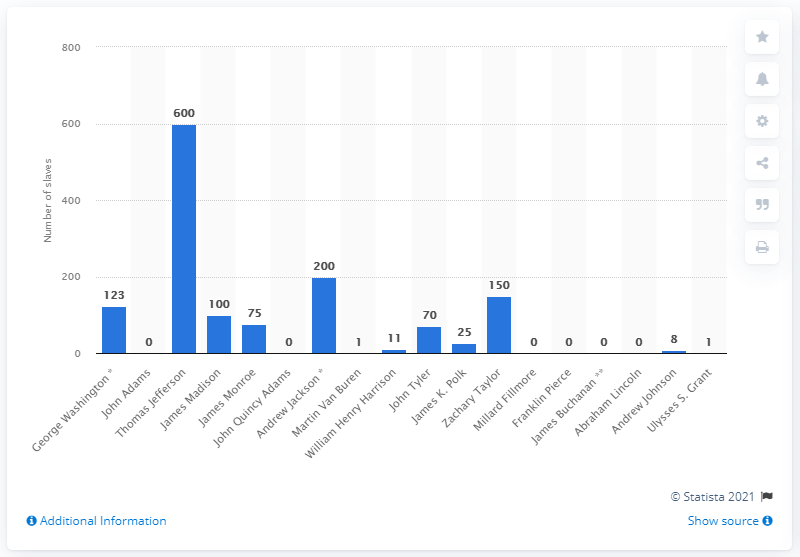Highlight a few significant elements in this photo. John Adams was the only President in United States history who never owned slaves. 